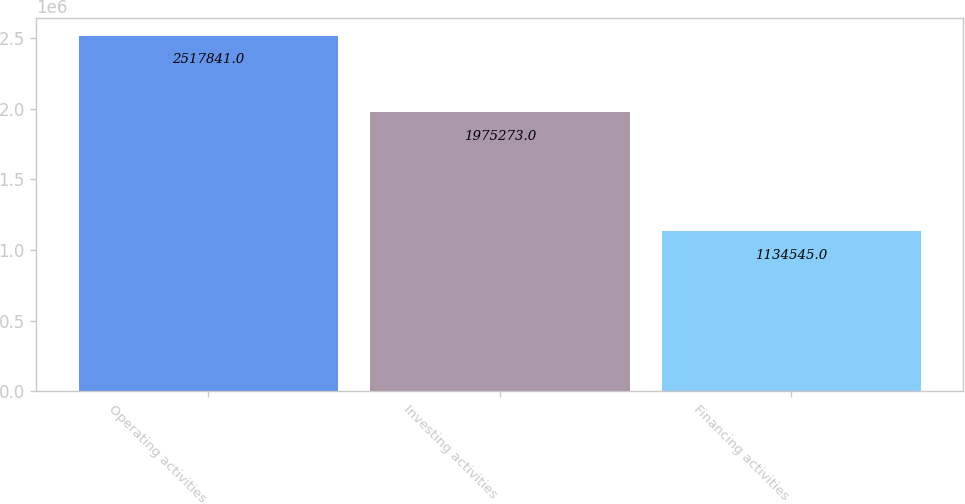<chart> <loc_0><loc_0><loc_500><loc_500><bar_chart><fcel>Operating activities<fcel>Investing activities<fcel>Financing activities<nl><fcel>2.51784e+06<fcel>1.97527e+06<fcel>1.13454e+06<nl></chart> 